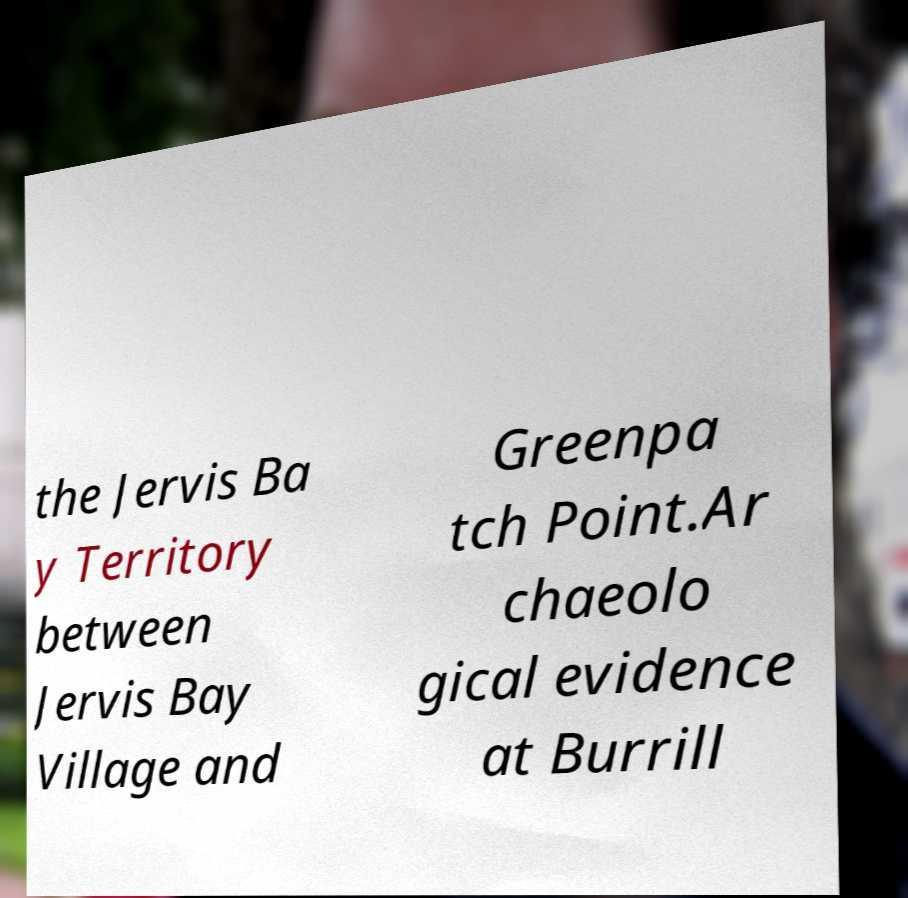Could you extract and type out the text from this image? the Jervis Ba y Territory between Jervis Bay Village and Greenpa tch Point.Ar chaeolo gical evidence at Burrill 